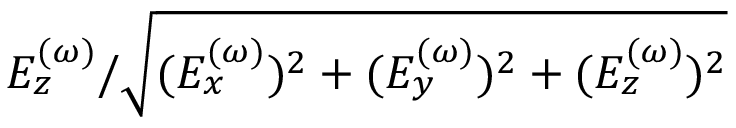Convert formula to latex. <formula><loc_0><loc_0><loc_500><loc_500>E _ { z } ^ { ( \omega ) } / \sqrt { ( E _ { x } ^ { ( \omega ) } ) ^ { 2 } + ( E _ { y } ^ { ( \omega ) } ) ^ { 2 } + ( E _ { z } ^ { ( \omega ) } ) ^ { 2 } }</formula> 